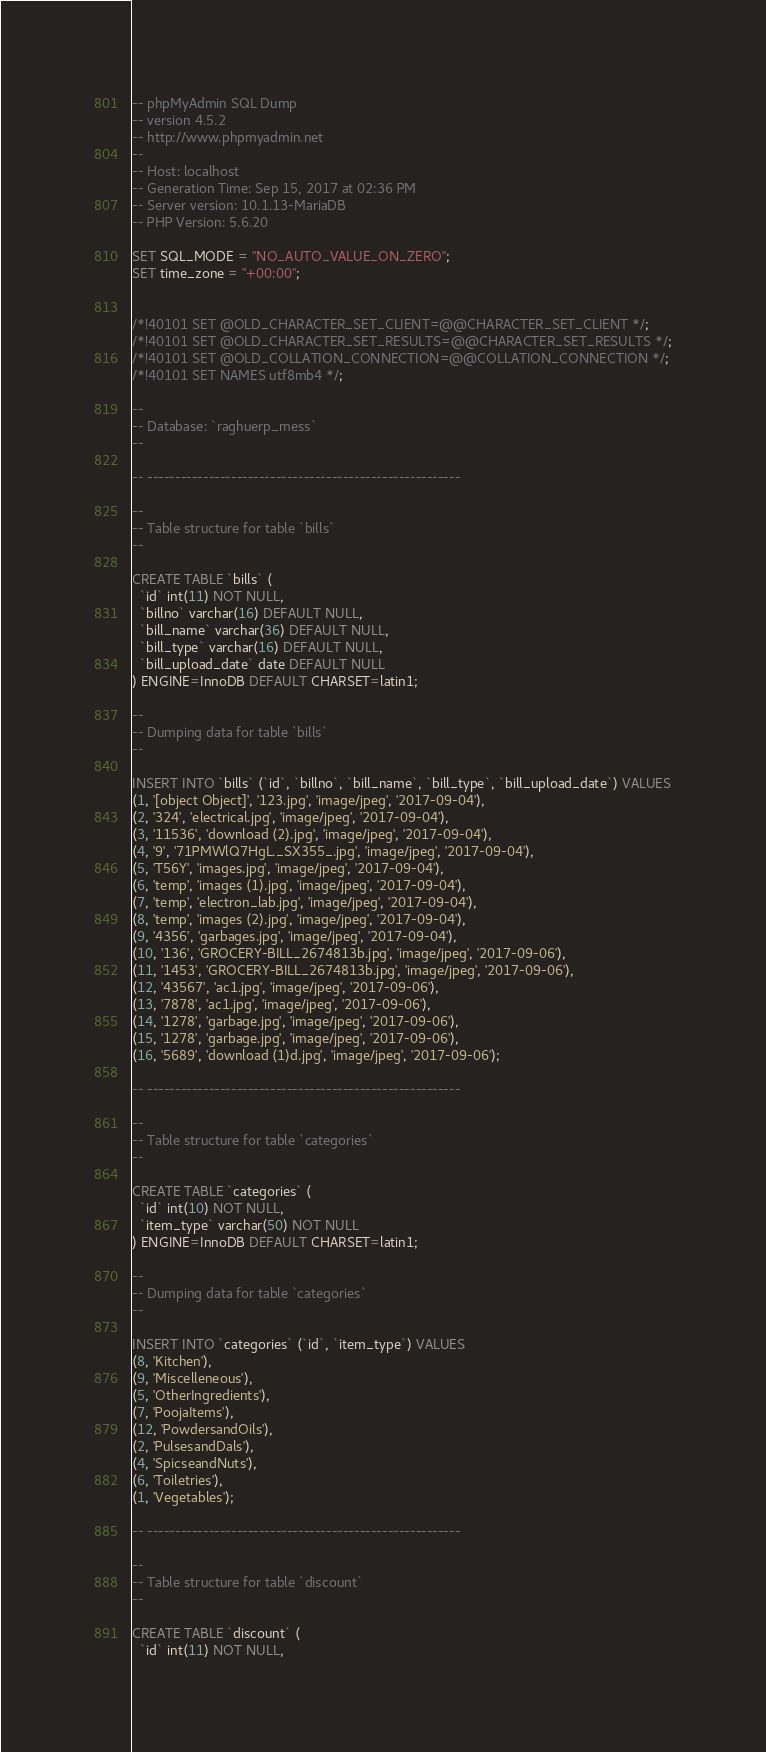Convert code to text. <code><loc_0><loc_0><loc_500><loc_500><_SQL_>-- phpMyAdmin SQL Dump
-- version 4.5.2
-- http://www.phpmyadmin.net
--
-- Host: localhost
-- Generation Time: Sep 15, 2017 at 02:36 PM
-- Server version: 10.1.13-MariaDB
-- PHP Version: 5.6.20

SET SQL_MODE = "NO_AUTO_VALUE_ON_ZERO";
SET time_zone = "+00:00";


/*!40101 SET @OLD_CHARACTER_SET_CLIENT=@@CHARACTER_SET_CLIENT */;
/*!40101 SET @OLD_CHARACTER_SET_RESULTS=@@CHARACTER_SET_RESULTS */;
/*!40101 SET @OLD_COLLATION_CONNECTION=@@COLLATION_CONNECTION */;
/*!40101 SET NAMES utf8mb4 */;

--
-- Database: `raghuerp_mess`
--

-- --------------------------------------------------------

--
-- Table structure for table `bills`
--

CREATE TABLE `bills` (
  `id` int(11) NOT NULL,
  `billno` varchar(16) DEFAULT NULL,
  `bill_name` varchar(36) DEFAULT NULL,
  `bill_type` varchar(16) DEFAULT NULL,
  `bill_upload_date` date DEFAULT NULL
) ENGINE=InnoDB DEFAULT CHARSET=latin1;

--
-- Dumping data for table `bills`
--

INSERT INTO `bills` (`id`, `billno`, `bill_name`, `bill_type`, `bill_upload_date`) VALUES
(1, '[object Object]', '123.jpg', 'image/jpeg', '2017-09-04'),
(2, '324', 'electrical.jpg', 'image/jpeg', '2017-09-04'),
(3, '11536', 'download (2).jpg', 'image/jpeg', '2017-09-04'),
(4, '9', '71PMWlQ7HgL._SX355_.jpg', 'image/jpeg', '2017-09-04'),
(5, 'T56Y', 'images.jpg', 'image/jpeg', '2017-09-04'),
(6, 'temp', 'images (1).jpg', 'image/jpeg', '2017-09-04'),
(7, 'temp', 'electron_lab.jpg', 'image/jpeg', '2017-09-04'),
(8, 'temp', 'images (2).jpg', 'image/jpeg', '2017-09-04'),
(9, '4356', 'garbages.jpg', 'image/jpeg', '2017-09-04'),
(10, '136', 'GROCERY-BILL_2674813b.jpg', 'image/jpeg', '2017-09-06'),
(11, '1453', 'GROCERY-BILL_2674813b.jpg', 'image/jpeg', '2017-09-06'),
(12, '43567', 'ac1.jpg', 'image/jpeg', '2017-09-06'),
(13, '7878', 'ac1.jpg', 'image/jpeg', '2017-09-06'),
(14, '1278', 'garbage.jpg', 'image/jpeg', '2017-09-06'),
(15, '1278', 'garbage.jpg', 'image/jpeg', '2017-09-06'),
(16, '5689', 'download (1)d.jpg', 'image/jpeg', '2017-09-06');

-- --------------------------------------------------------

--
-- Table structure for table `categories`
--

CREATE TABLE `categories` (
  `id` int(10) NOT NULL,
  `item_type` varchar(50) NOT NULL
) ENGINE=InnoDB DEFAULT CHARSET=latin1;

--
-- Dumping data for table `categories`
--

INSERT INTO `categories` (`id`, `item_type`) VALUES
(8, 'Kitchen'),
(9, 'Miscelleneous'),
(5, 'OtherIngredients'),
(7, 'PoojaItems'),
(12, 'PowdersandOils'),
(2, 'PulsesandDals'),
(4, 'SpicseandNuts'),
(6, 'Toiletries'),
(1, 'Vegetables');

-- --------------------------------------------------------

--
-- Table structure for table `discount`
--

CREATE TABLE `discount` (
  `id` int(11) NOT NULL,</code> 